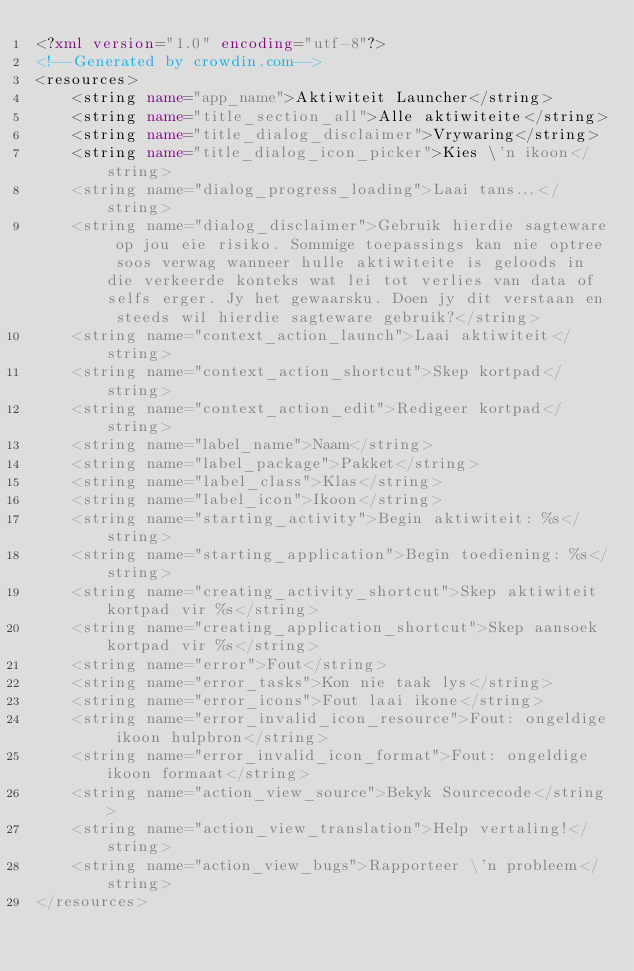<code> <loc_0><loc_0><loc_500><loc_500><_XML_><?xml version="1.0" encoding="utf-8"?>
<!--Generated by crowdin.com-->
<resources>
    <string name="app_name">Aktiwiteit Launcher</string>
    <string name="title_section_all">Alle aktiwiteite</string>
    <string name="title_dialog_disclaimer">Vrywaring</string>
    <string name="title_dialog_icon_picker">Kies \'n ikoon</string>
    <string name="dialog_progress_loading">Laai tans...</string>
    <string name="dialog_disclaimer">Gebruik hierdie sagteware op jou eie risiko. Sommige toepassings kan nie optree soos verwag wanneer hulle aktiwiteite is geloods in die verkeerde konteks wat lei tot verlies van data of selfs erger. Jy het gewaarsku. Doen jy dit verstaan en steeds wil hierdie sagteware gebruik?</string>
    <string name="context_action_launch">Laai aktiwiteit</string>
    <string name="context_action_shortcut">Skep kortpad</string>
    <string name="context_action_edit">Redigeer kortpad</string>
    <string name="label_name">Naam</string>
    <string name="label_package">Pakket</string>
    <string name="label_class">Klas</string>
    <string name="label_icon">Ikoon</string>
    <string name="starting_activity">Begin aktiwiteit: %s</string>
    <string name="starting_application">Begin toediening: %s</string>
    <string name="creating_activity_shortcut">Skep aktiwiteit kortpad vir %s</string>
    <string name="creating_application_shortcut">Skep aansoek kortpad vir %s</string>
    <string name="error">Fout</string>
    <string name="error_tasks">Kon nie taak lys</string>
    <string name="error_icons">Fout laai ikone</string>
    <string name="error_invalid_icon_resource">Fout: ongeldige ikoon hulpbron</string>
    <string name="error_invalid_icon_format">Fout: ongeldige ikoon formaat</string>
    <string name="action_view_source">Bekyk Sourcecode</string>
    <string name="action_view_translation">Help vertaling!</string>
    <string name="action_view_bugs">Rapporteer \'n probleem</string>
</resources>
</code> 